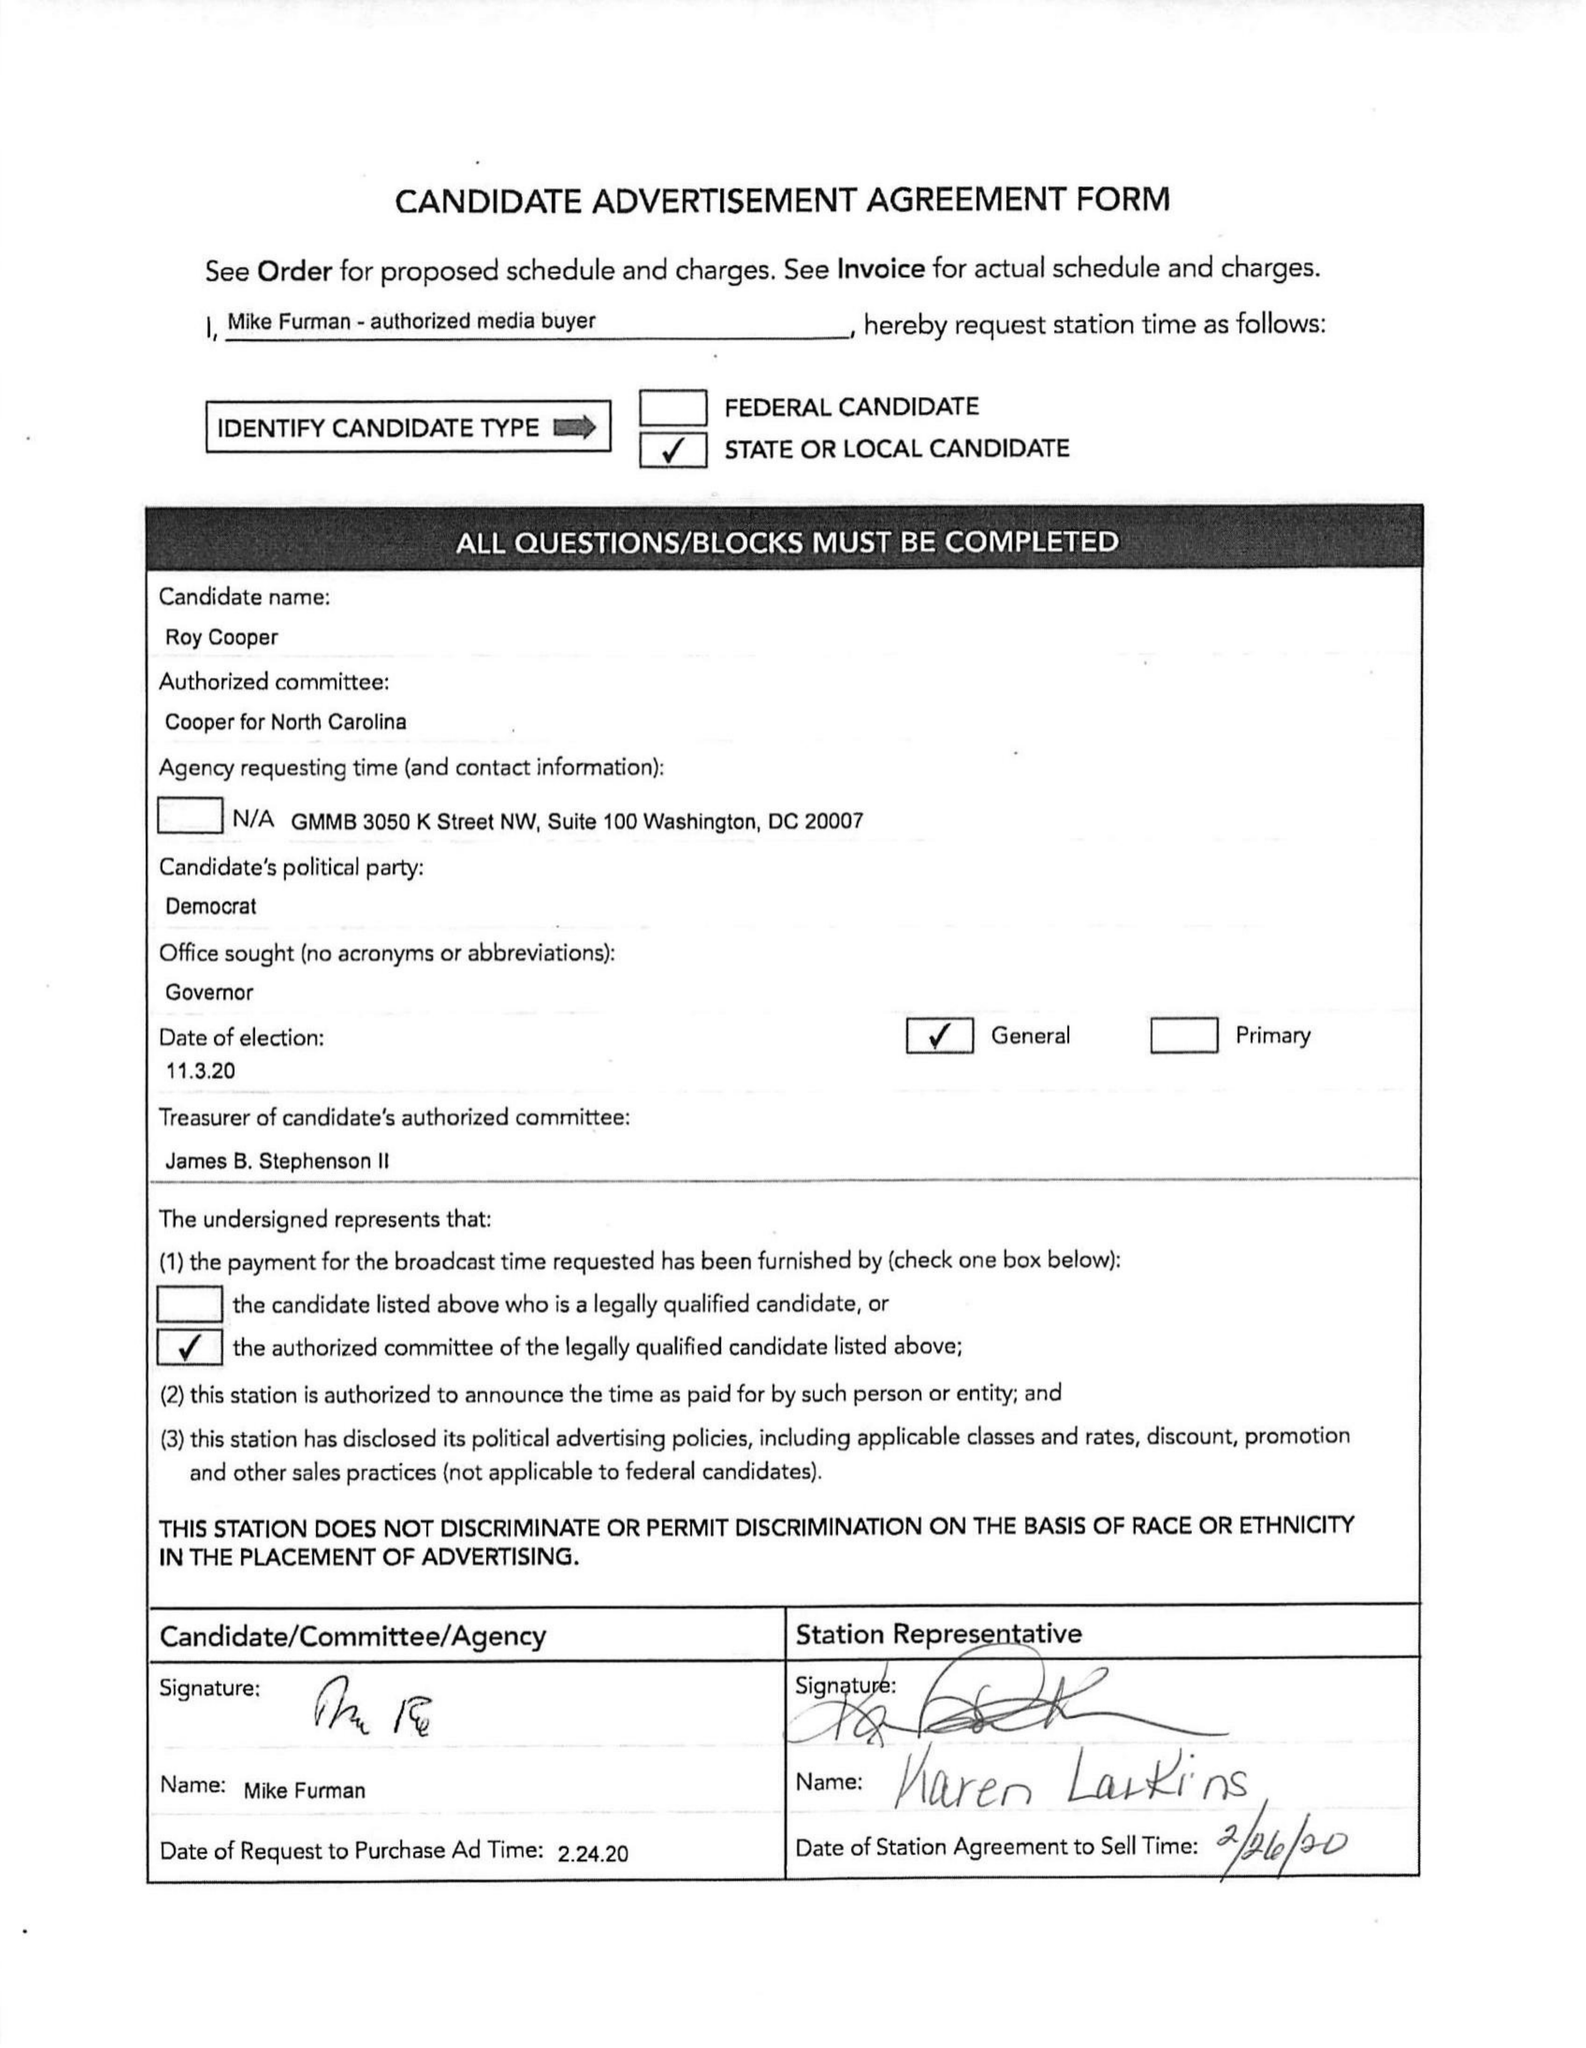What is the value for the flight_to?
Answer the question using a single word or phrase. None 